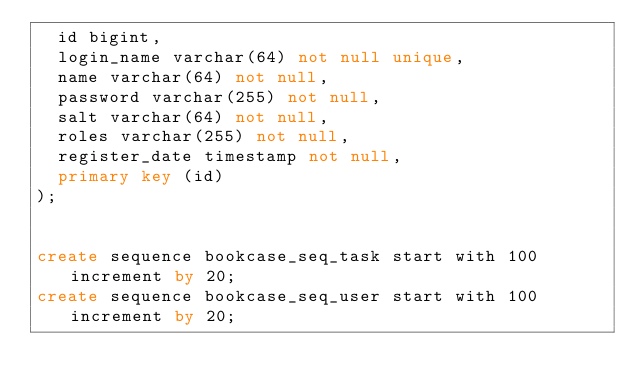Convert code to text. <code><loc_0><loc_0><loc_500><loc_500><_SQL_>	id bigint,
	login_name varchar(64) not null unique,
	name varchar(64) not null,
	password varchar(255) not null,
	salt varchar(64) not null,
	roles varchar(255) not null,
	register_date timestamp not null,
	primary key (id)
);


create sequence bookcase_seq_task start with 100 increment by 20;
create sequence bookcase_seq_user start with 100 increment by 20;</code> 